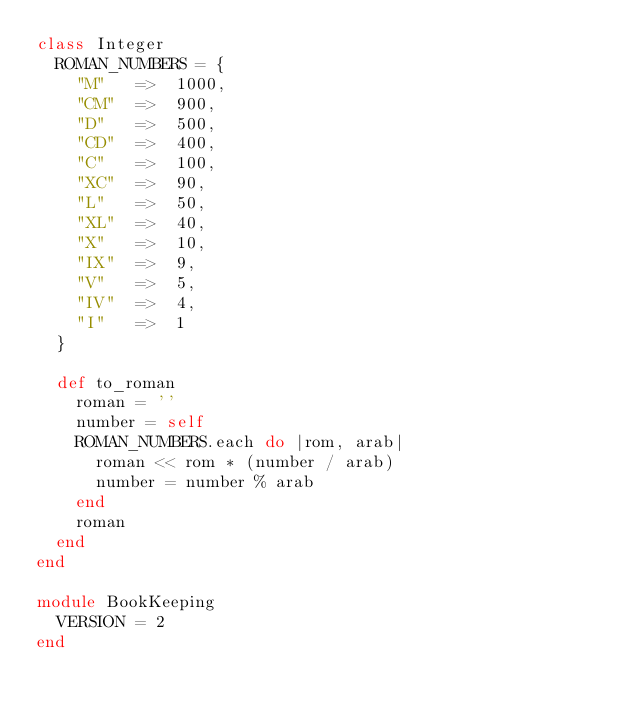<code> <loc_0><loc_0><loc_500><loc_500><_Ruby_>class Integer
  ROMAN_NUMBERS = {
    "M"   =>  1000,
    "CM"  =>  900,
    "D"   =>  500,
    "CD"  =>  400,
    "C"   =>  100,
    "XC"  =>  90,
    "L"   =>  50,
    "XL"  =>  40,
    "X"   =>  10,
    "IX"  =>  9,
    "V"   =>  5,
    "IV"  =>  4,
    "I"   =>  1
  }
  
  def to_roman
    roman = ''
    number = self
    ROMAN_NUMBERS.each do |rom, arab|
      roman << rom * (number / arab)
      number = number % arab
    end
    roman
  end
end

module BookKeeping
  VERSION = 2
end
</code> 